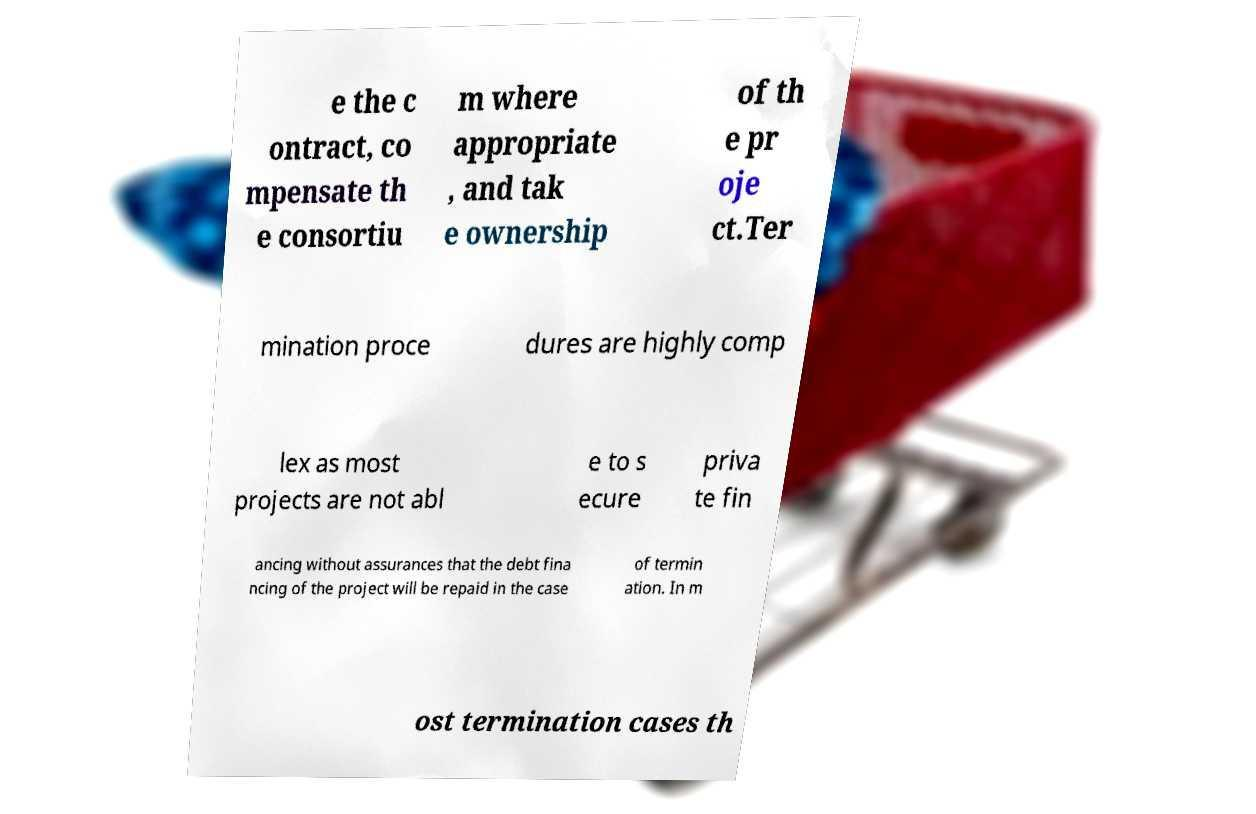Could you extract and type out the text from this image? e the c ontract, co mpensate th e consortiu m where appropriate , and tak e ownership of th e pr oje ct.Ter mination proce dures are highly comp lex as most projects are not abl e to s ecure priva te fin ancing without assurances that the debt fina ncing of the project will be repaid in the case of termin ation. In m ost termination cases th 